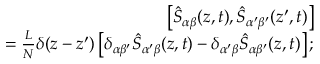Convert formula to latex. <formula><loc_0><loc_0><loc_500><loc_500>\begin{array} { r l r } & { \left [ \hat { S } _ { \alpha \beta } ( z , t ) , \hat { S } _ { \alpha ^ { \prime } \beta ^ { \prime } } ( z ^ { \prime } , t ) \right ] } \\ & { = \frac { L } { N } \delta ( z - z ^ { \prime } ) \left [ \delta _ { \alpha \beta ^ { \prime } } \hat { S } _ { \alpha ^ { \prime } \beta } ( z , t ) - \delta _ { \alpha ^ { \prime } \beta } \hat { S } _ { \alpha \beta ^ { \prime } } ( z , t ) \right ] ; } \end{array}</formula> 